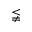Convert formula to latex. <formula><loc_0><loc_0><loc_500><loc_500>\lneqq</formula> 